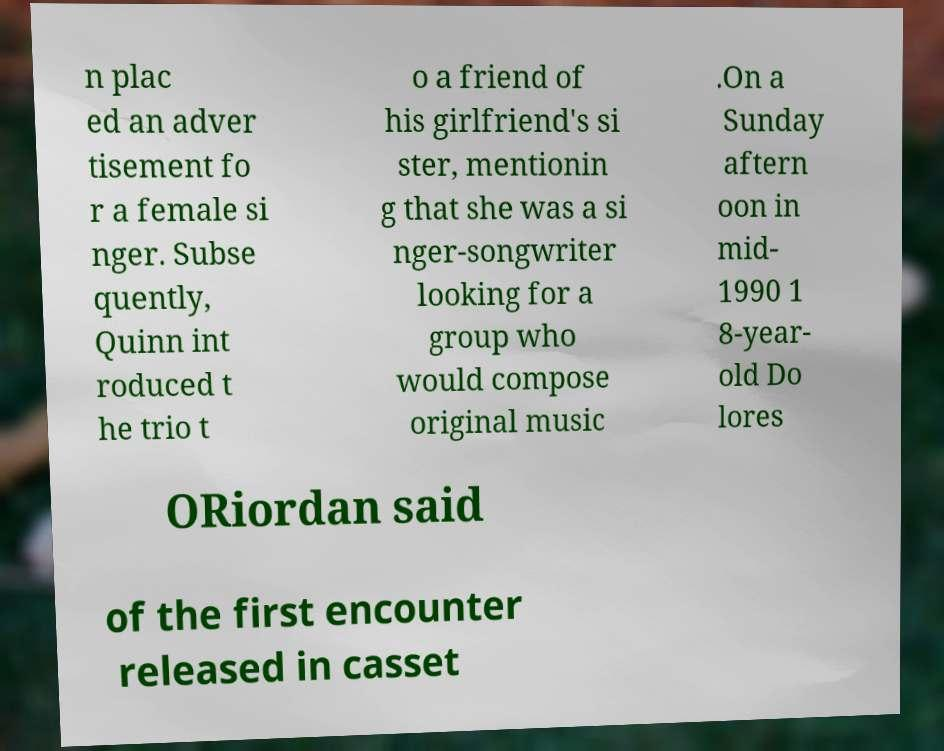For documentation purposes, I need the text within this image transcribed. Could you provide that? n plac ed an adver tisement fo r a female si nger. Subse quently, Quinn int roduced t he trio t o a friend of his girlfriend's si ster, mentionin g that she was a si nger-songwriter looking for a group who would compose original music .On a Sunday aftern oon in mid- 1990 1 8-year- old Do lores ORiordan said of the first encounter released in casset 